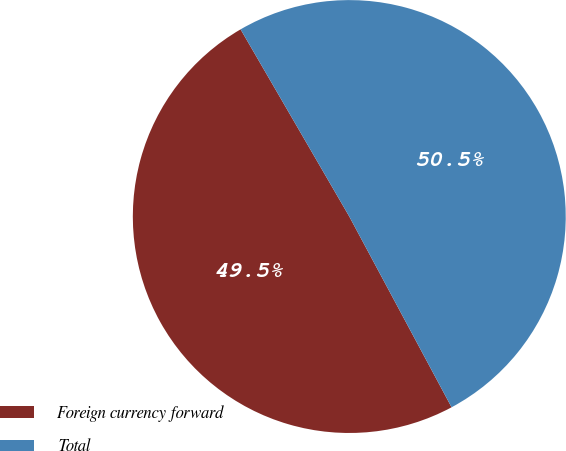<chart> <loc_0><loc_0><loc_500><loc_500><pie_chart><fcel>Foreign currency forward<fcel>Total<nl><fcel>49.46%<fcel>50.54%<nl></chart> 